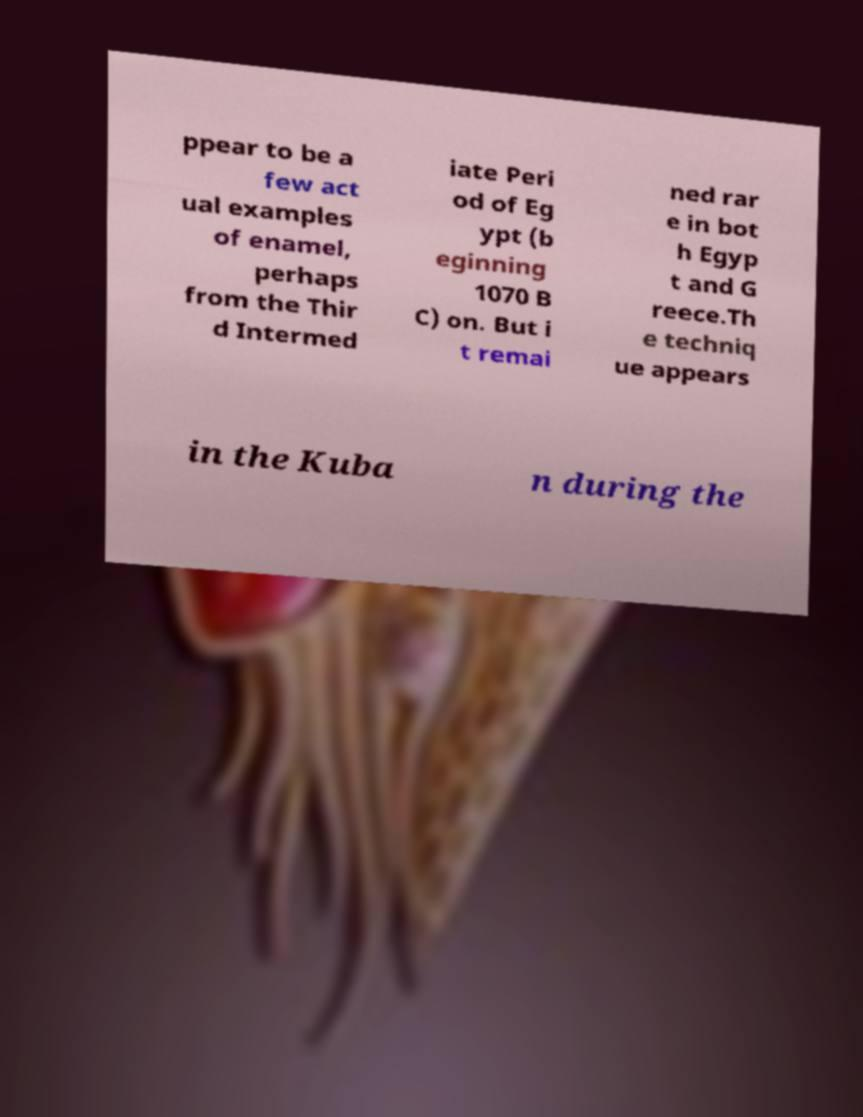For documentation purposes, I need the text within this image transcribed. Could you provide that? ppear to be a few act ual examples of enamel, perhaps from the Thir d Intermed iate Peri od of Eg ypt (b eginning 1070 B C) on. But i t remai ned rar e in bot h Egyp t and G reece.Th e techniq ue appears in the Kuba n during the 